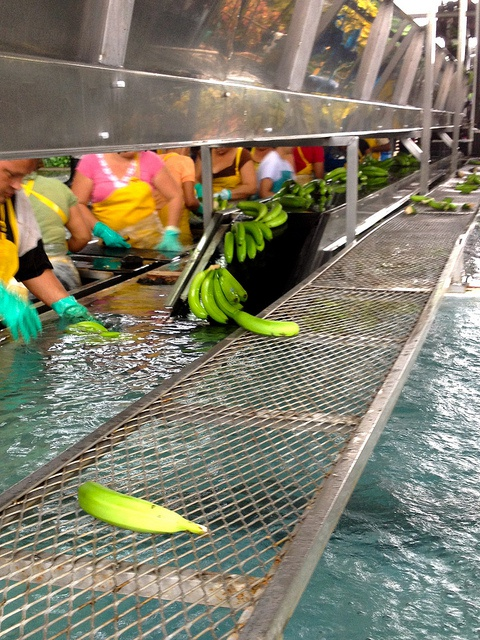Describe the objects in this image and their specific colors. I can see people in gray, salmon, orange, and red tones, people in gray, black, brown, orange, and maroon tones, banana in gray, olive, black, and darkgreen tones, banana in gray, yellow, khaki, and lime tones, and people in gray, tan, khaki, and brown tones in this image. 